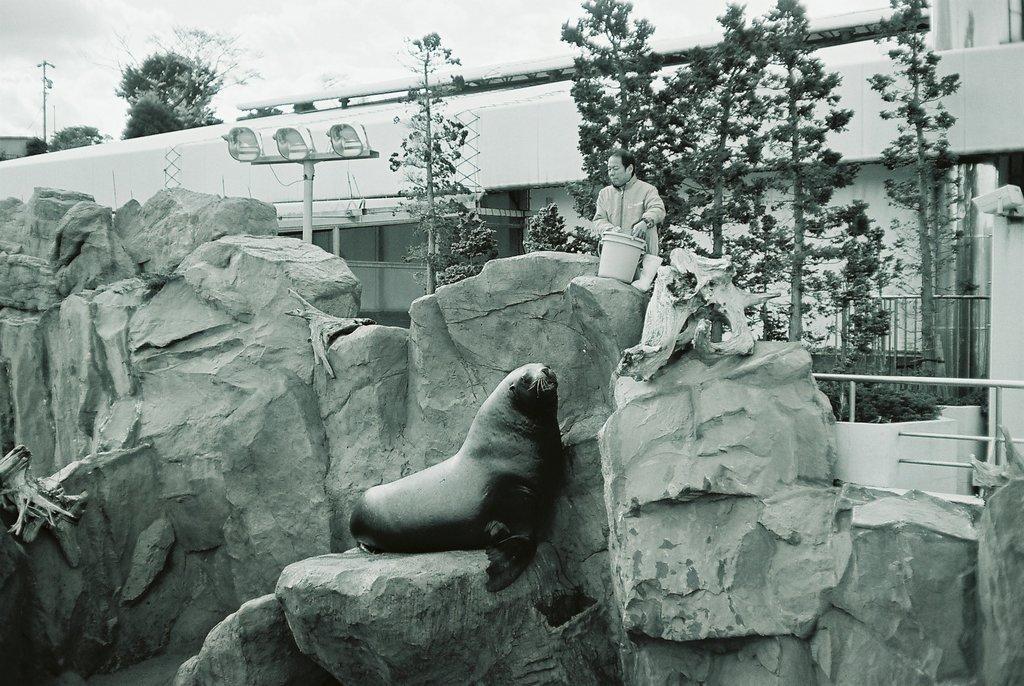Describe this image in one or two sentences. In this picture I can see a seal on the rocks and I can see a man standing and holding a bucket and I can see trees and building in the back and I can see cloudy sky and few lights to the pole. 